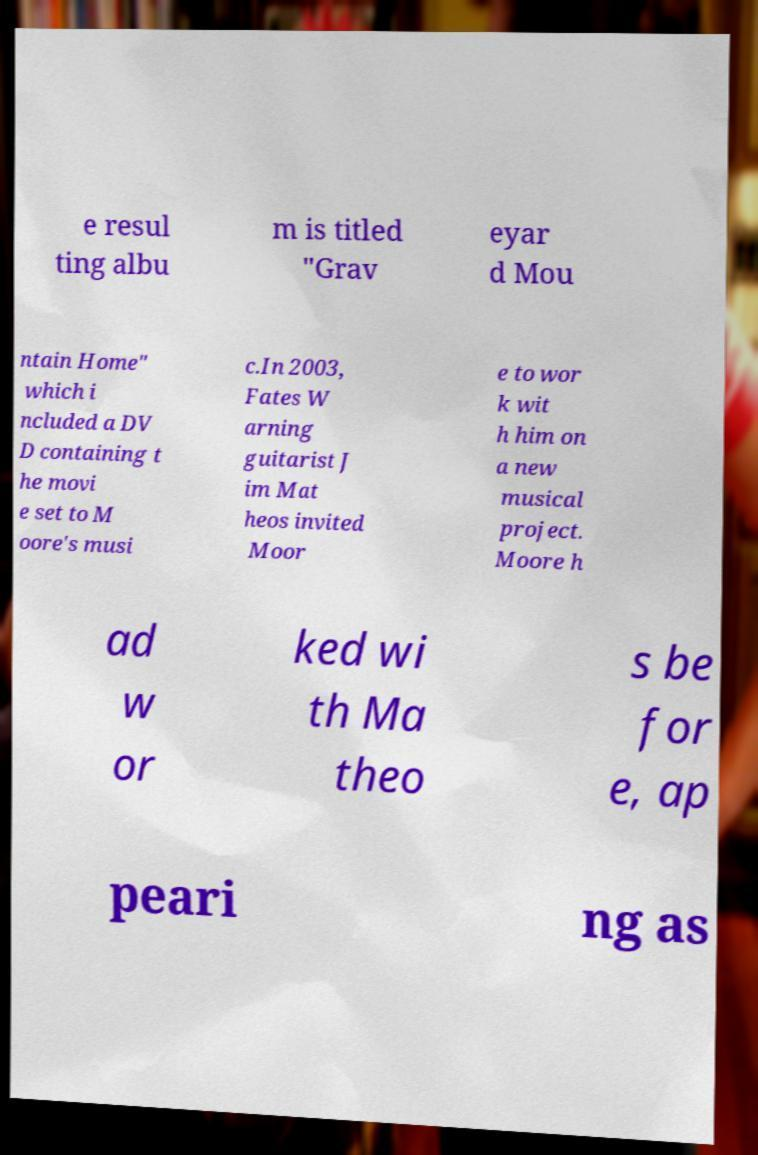Can you accurately transcribe the text from the provided image for me? e resul ting albu m is titled "Grav eyar d Mou ntain Home" which i ncluded a DV D containing t he movi e set to M oore's musi c.In 2003, Fates W arning guitarist J im Mat heos invited Moor e to wor k wit h him on a new musical project. Moore h ad w or ked wi th Ma theo s be for e, ap peari ng as 